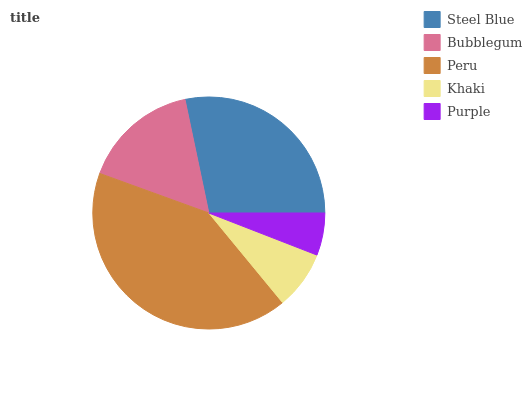Is Purple the minimum?
Answer yes or no. Yes. Is Peru the maximum?
Answer yes or no. Yes. Is Bubblegum the minimum?
Answer yes or no. No. Is Bubblegum the maximum?
Answer yes or no. No. Is Steel Blue greater than Bubblegum?
Answer yes or no. Yes. Is Bubblegum less than Steel Blue?
Answer yes or no. Yes. Is Bubblegum greater than Steel Blue?
Answer yes or no. No. Is Steel Blue less than Bubblegum?
Answer yes or no. No. Is Bubblegum the high median?
Answer yes or no. Yes. Is Bubblegum the low median?
Answer yes or no. Yes. Is Peru the high median?
Answer yes or no. No. Is Khaki the low median?
Answer yes or no. No. 